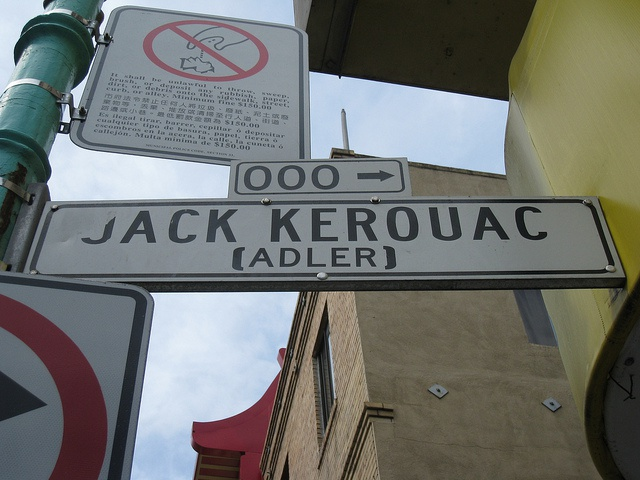Describe the objects in this image and their specific colors. I can see various objects in this image with different colors. 